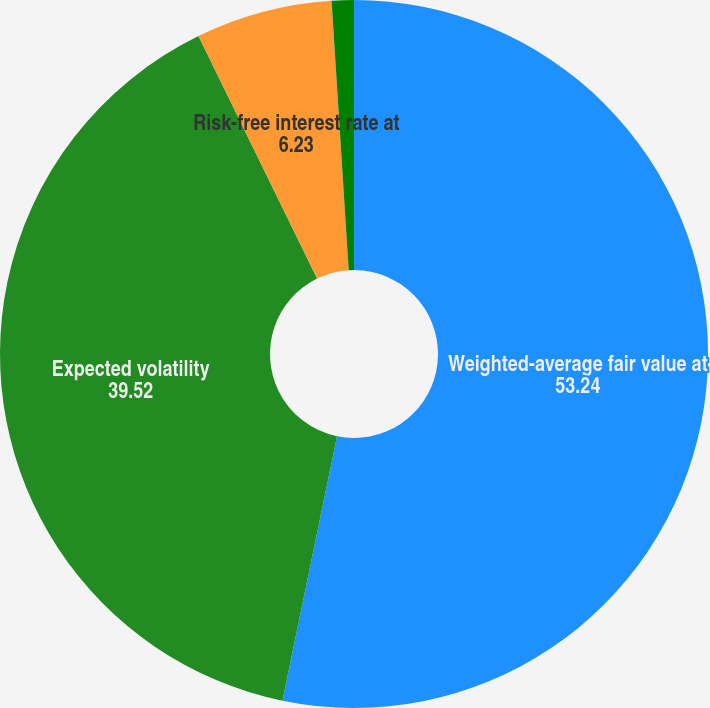Convert chart to OTSL. <chart><loc_0><loc_0><loc_500><loc_500><pie_chart><fcel>Weighted-average fair value at<fcel>Expected volatility<fcel>Risk-free interest rate at<fcel>Dividend yield<nl><fcel>53.24%<fcel>39.52%<fcel>6.23%<fcel>1.01%<nl></chart> 